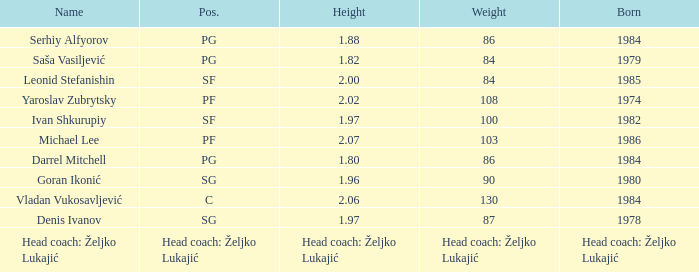What was the mass of serhiy alfyorov? 86.0. 